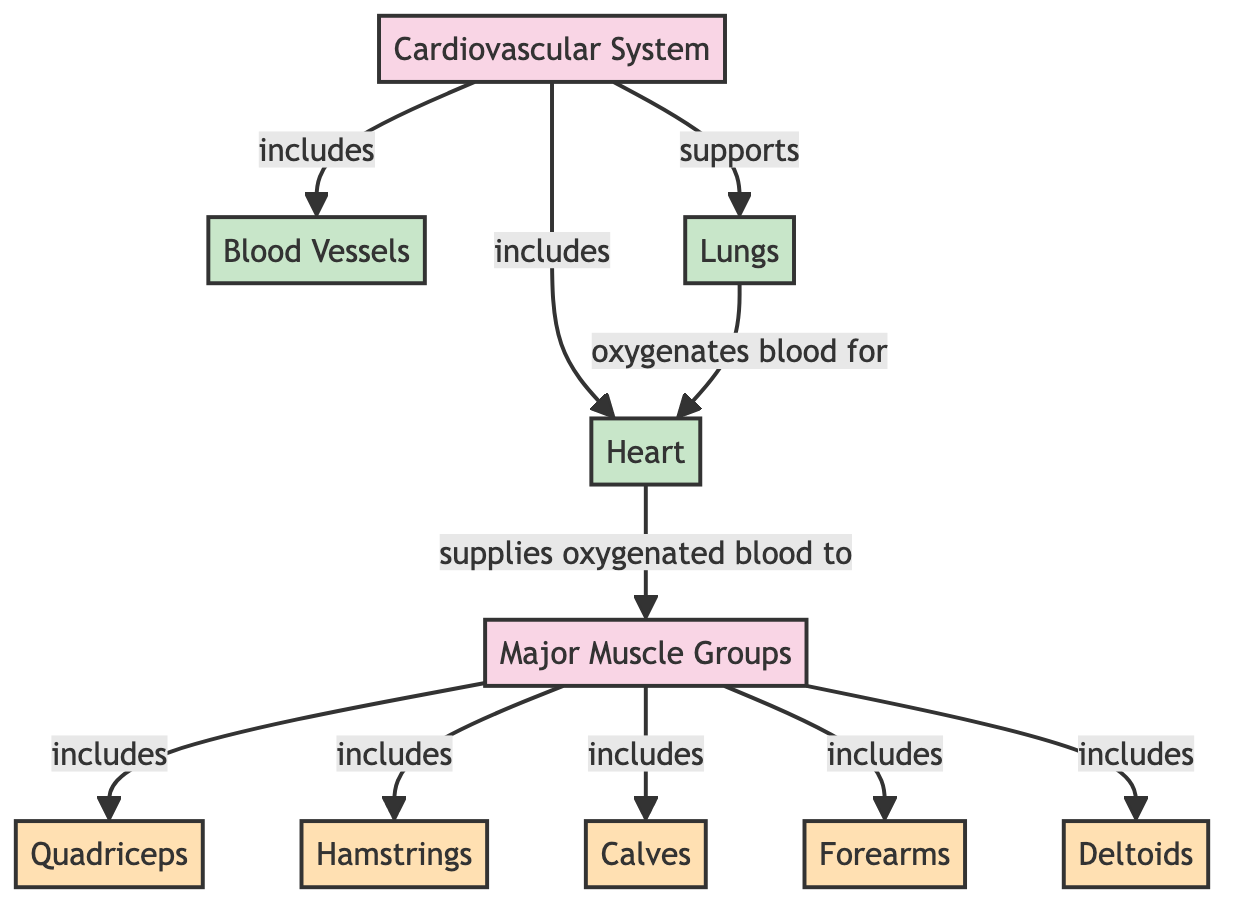What are the major muscle groups included in the diagram? The diagram lists the major muscle groups as: Quadriceps, Hamstrings, Calves, Forearms, and Deltoids.
Answer: Quadriceps, Hamstrings, Calves, Forearms, Deltoids How many organ components are included in the cardiovascular system? The cardiovascular system includes three organ components: Heart, Blood Vessels, and Lungs.
Answer: 3 What does the heart supply to the major muscle groups? The heart supplies oxygenated blood to the major muscle groups as indicated by the relationship arrows.
Answer: Oxygenated blood What is the role of the lungs in relation to the heart? The lungs oxygenate blood for the heart, thus playing a critical role in the supply chain of oxygen to the body during a hockey game.
Answer: Oxygenates blood What is the relationship between blood vessels and the major muscle groups? Blood vessels are part of the cardiovascular system and are crucial for the delivery of nutrients and oxygen, thus supporting the major muscle groups.
Answer: Supports Which major muscle group is mentioned last in the list? The list of major muscle groups includes Forearms last, as shown in the flow of relationships from the Major Muscle Groups node.
Answer: Forearms How many total major muscle groups are represented in the diagram? The diagram explicitly lists five major muscle groups, as indicated by the direct relationship links to the Major Muscle Groups node.
Answer: 5 What is the function of the cardiovascular system in athletic physiology? The cardiovascular system supports the delivery of oxygenated blood and nutrients to major muscle groups and is integral during athletic activities such as a hockey game.
Answer: Supports delivery of oxygenated blood Which node is connected to the lungs? The lungs are connected to the heart, as they oxygenate blood which then supplies the heart for circulation.
Answer: Heart 